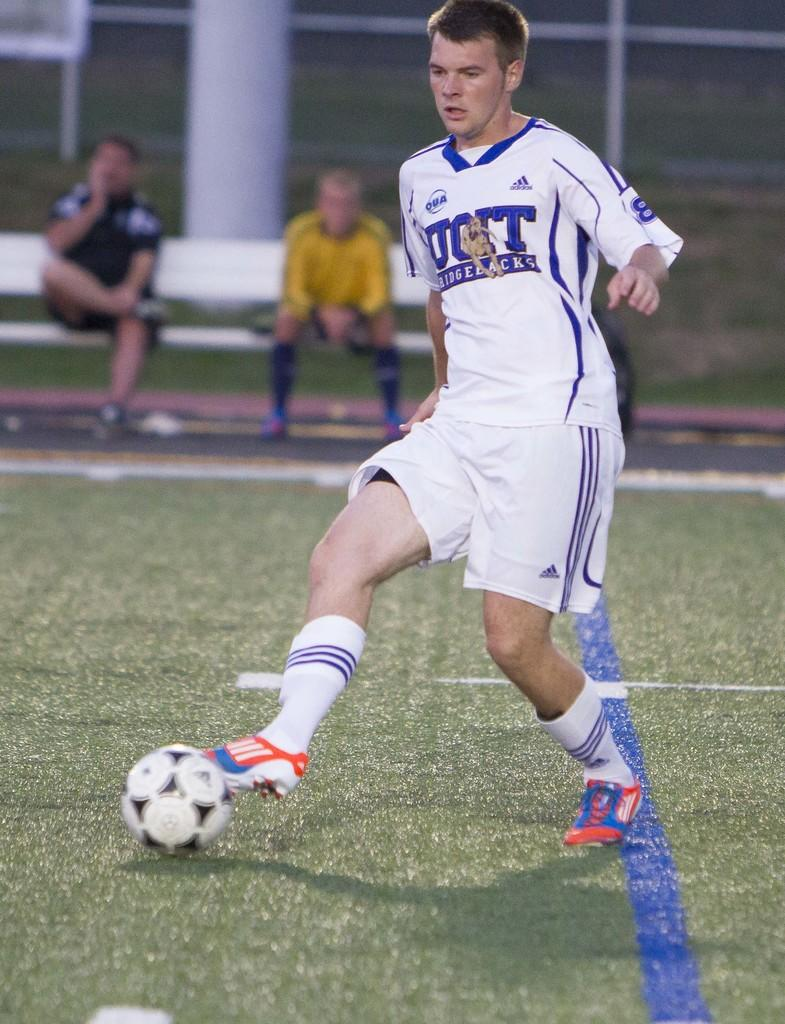What is the man in the image doing? The man is running on the ground. What object can be seen in the image besides the man? There is a ball in the image. What can be observed in the background of the image? There are people sitting in the background. What type of attraction is the man visiting in the image? There is no indication of an attraction in the image; the man is simply running on the ground. Can you see any bananas in the image? There are no bananas present in the image. 